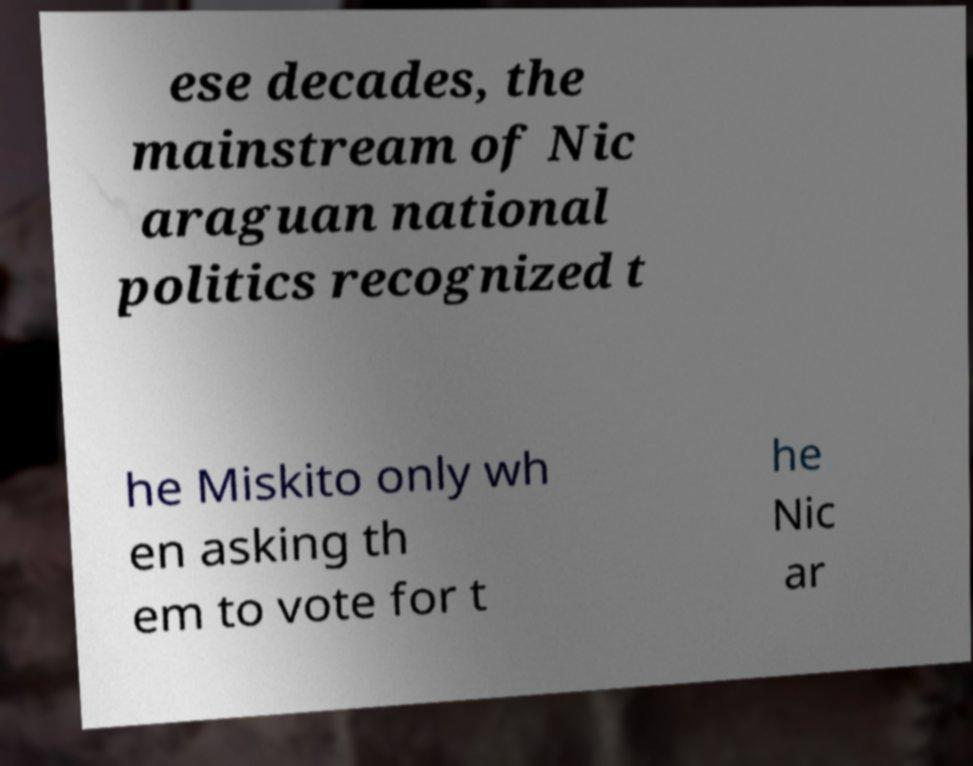Could you extract and type out the text from this image? ese decades, the mainstream of Nic araguan national politics recognized t he Miskito only wh en asking th em to vote for t he Nic ar 